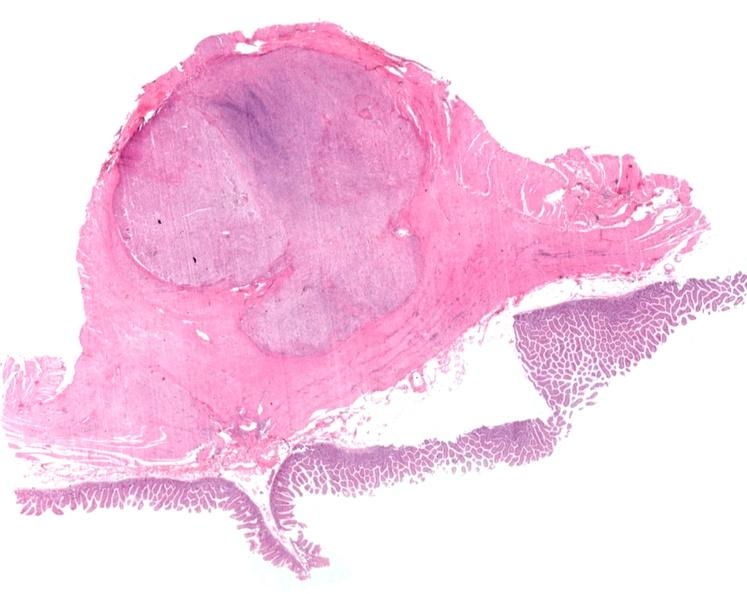what is present?
Answer the question using a single word or phrase. Gastrointestinal 